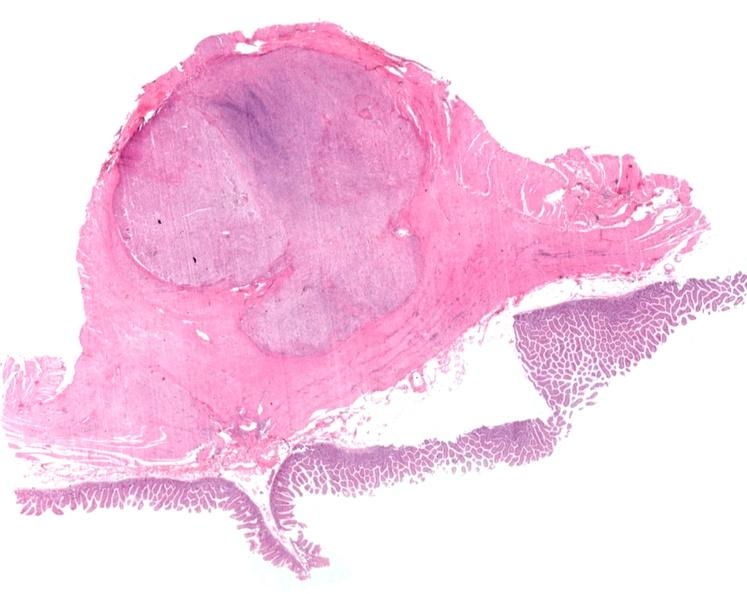what is present?
Answer the question using a single word or phrase. Gastrointestinal 